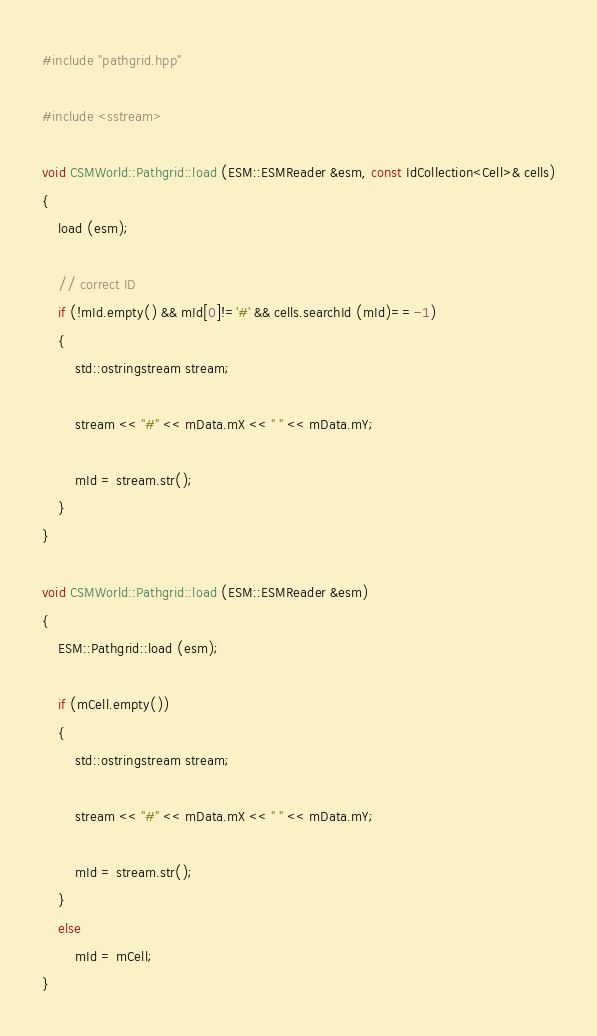<code> <loc_0><loc_0><loc_500><loc_500><_C++_>
#include "pathgrid.hpp"

#include <sstream>

void CSMWorld::Pathgrid::load (ESM::ESMReader &esm, const IdCollection<Cell>& cells)
{
    load (esm);

    // correct ID
    if (!mId.empty() && mId[0]!='#' && cells.searchId (mId)==-1)
    {
        std::ostringstream stream;

        stream << "#" << mData.mX << " " << mData.mY;

        mId = stream.str();
    }
}

void CSMWorld::Pathgrid::load (ESM::ESMReader &esm)
{
    ESM::Pathgrid::load (esm);

    if (mCell.empty())
    {
        std::ostringstream stream;

        stream << "#" << mData.mX << " " << mData.mY;

        mId = stream.str();
    }
    else
        mId = mCell;
}
</code> 